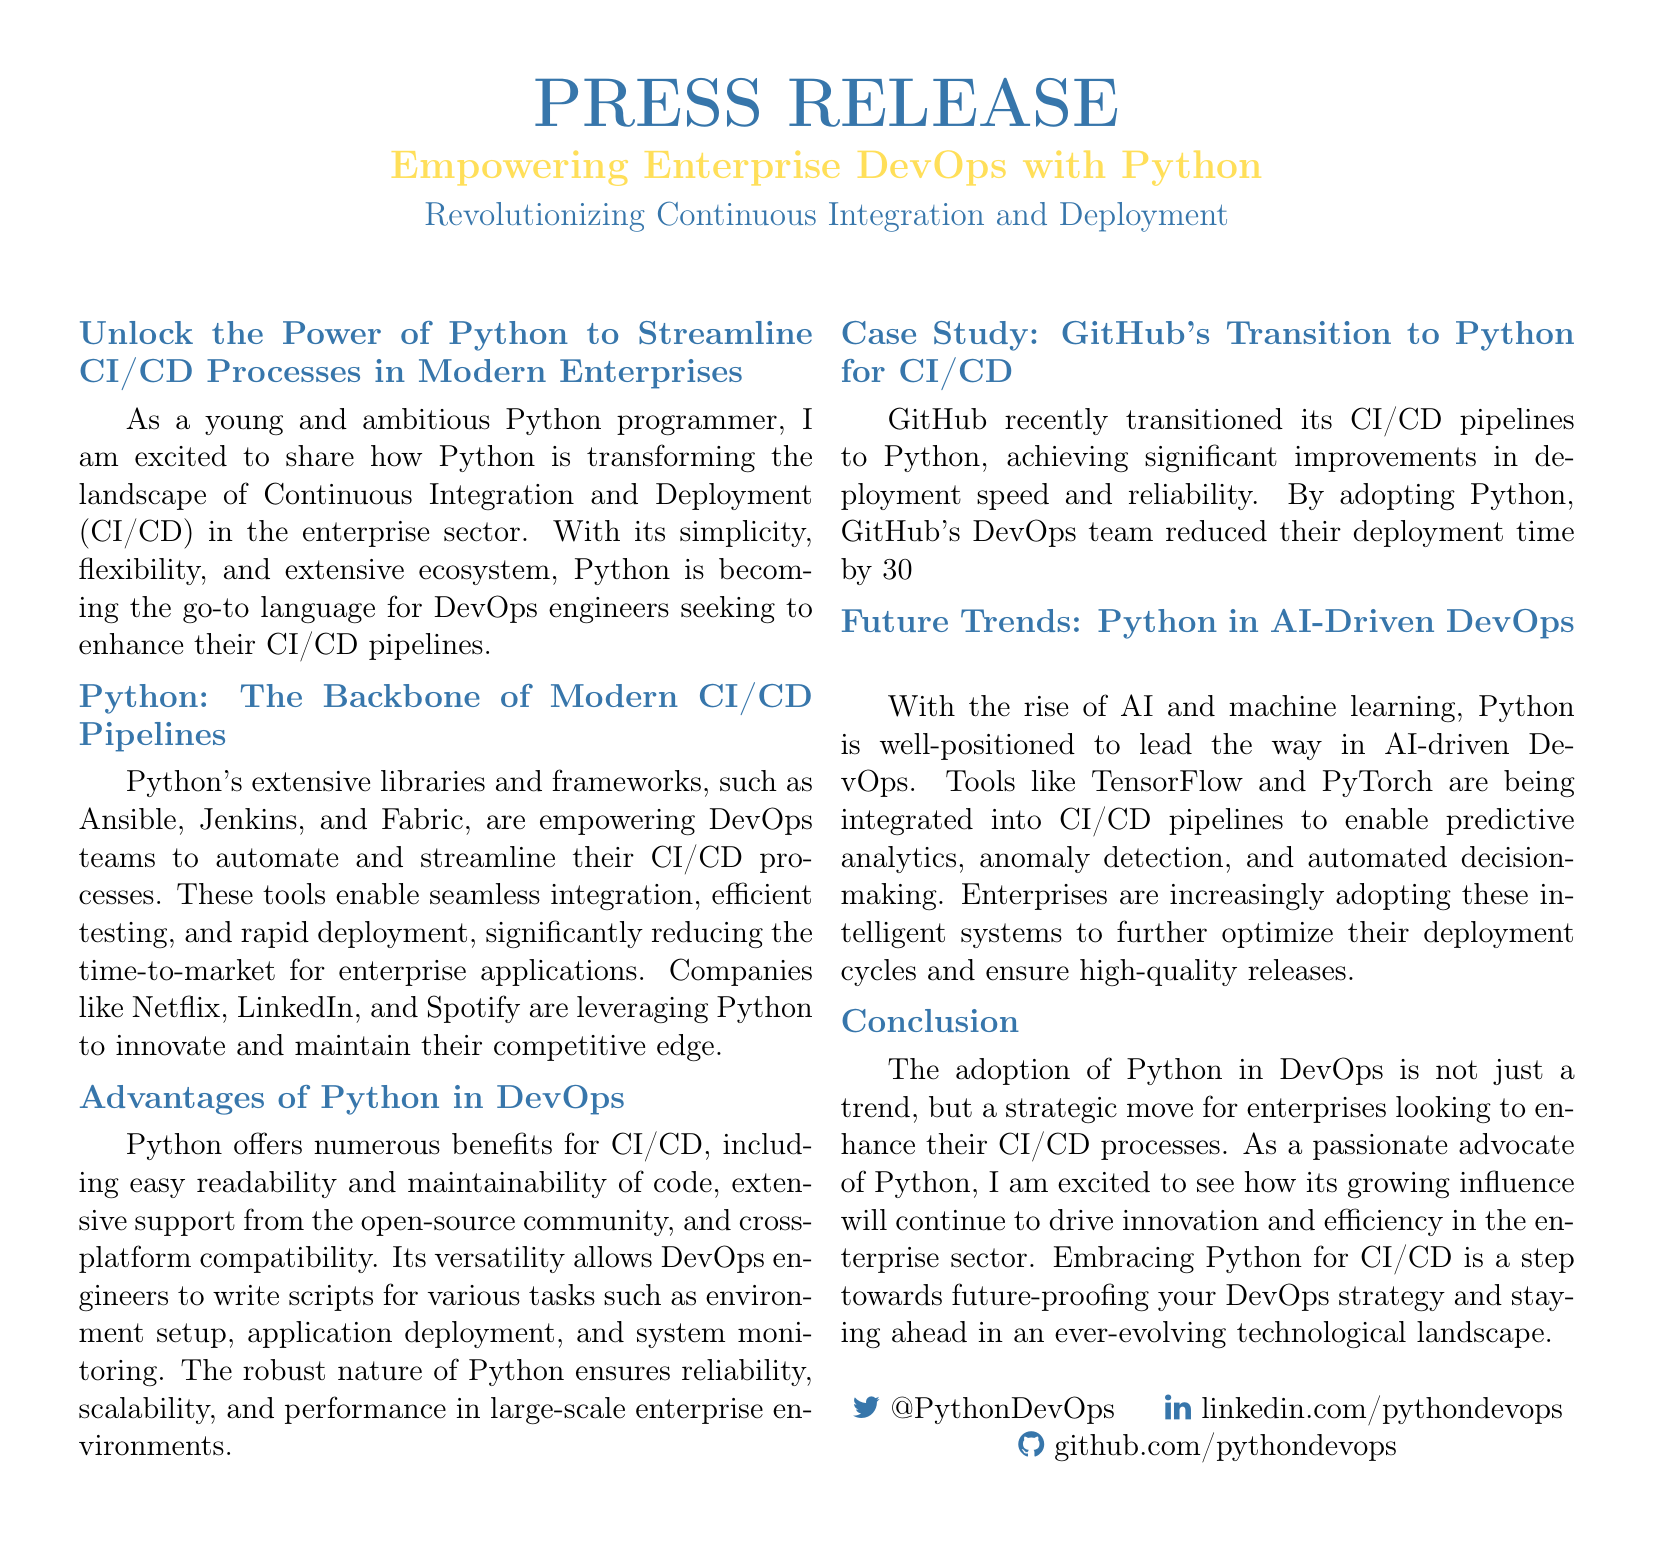What is the main topic of the press release? The main topic is the influence of Python in enhancing Continuous Integration and Deployment processes in enterprises.
Answer: Empowering Enterprise DevOps with Python What is one advantage of using Python in DevOps mentioned in the document? The document lists easy readability and maintainability of code as an advantage.
Answer: Easy readability What percentage did GitHub reduce their deployment time by after transitioning to Python? The document states GitHub reduced their deployment time by 30%.
Answer: 30% Name one tool mentioned that is empowering DevOps teams for CI/CD processes. The press release mentions Ansible as one of the tools.
Answer: Ansible What is highlighted as a future trend for Python in DevOps? The document indicates the rise of AI and machine learning as a future trend.
Answer: AI and machine learning What significant improvement did GitHub achieve after adopting Python? GitHub achieved significant improvements in deployment speed and reliability.
Answer: Deployment speed and reliability Who are two companies mentioned that leverage Python in their DevOps practices? Netflix and LinkedIn are two companies mentioned in the document.
Answer: Netflix and LinkedIn What is the role of TensorFlow and PyTorch according to the document? They are being integrated into CI/CD pipelines for predictive analytics and anomaly detection.
Answer: Predictive analytics and anomaly detection 